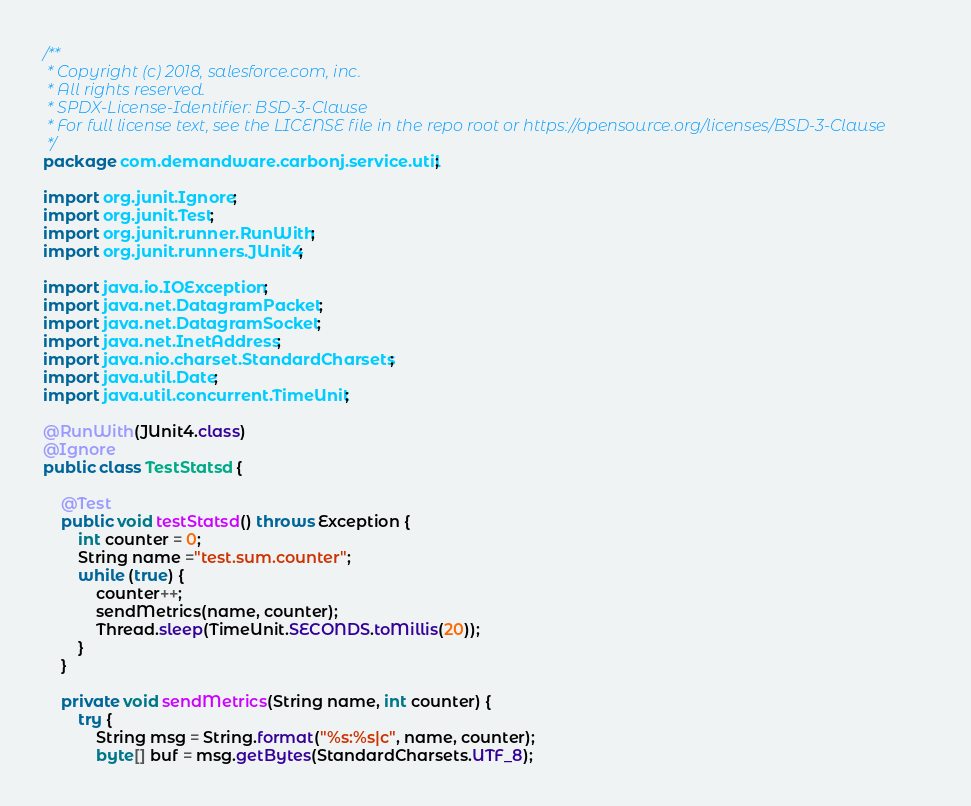<code> <loc_0><loc_0><loc_500><loc_500><_Java_>/**
 * Copyright (c) 2018, salesforce.com, inc.
 * All rights reserved.
 * SPDX-License-Identifier: BSD-3-Clause
 * For full license text, see the LICENSE file in the repo root or https://opensource.org/licenses/BSD-3-Clause
 */
package com.demandware.carbonj.service.util;

import org.junit.Ignore;
import org.junit.Test;
import org.junit.runner.RunWith;
import org.junit.runners.JUnit4;

import java.io.IOException;
import java.net.DatagramPacket;
import java.net.DatagramSocket;
import java.net.InetAddress;
import java.nio.charset.StandardCharsets;
import java.util.Date;
import java.util.concurrent.TimeUnit;

@RunWith(JUnit4.class)
@Ignore
public class TestStatsd {
    
    @Test
    public void testStatsd() throws Exception {
        int counter = 0;
        String name ="test.sum.counter";
        while (true) {
            counter++;
            sendMetrics(name, counter);
            Thread.sleep(TimeUnit.SECONDS.toMillis(20));
        }
    }

    private void sendMetrics(String name, int counter) {
        try {
            String msg = String.format("%s:%s|c", name, counter);
            byte[] buf = msg.getBytes(StandardCharsets.UTF_8);</code> 